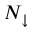Convert formula to latex. <formula><loc_0><loc_0><loc_500><loc_500>N _ { \downarrow }</formula> 